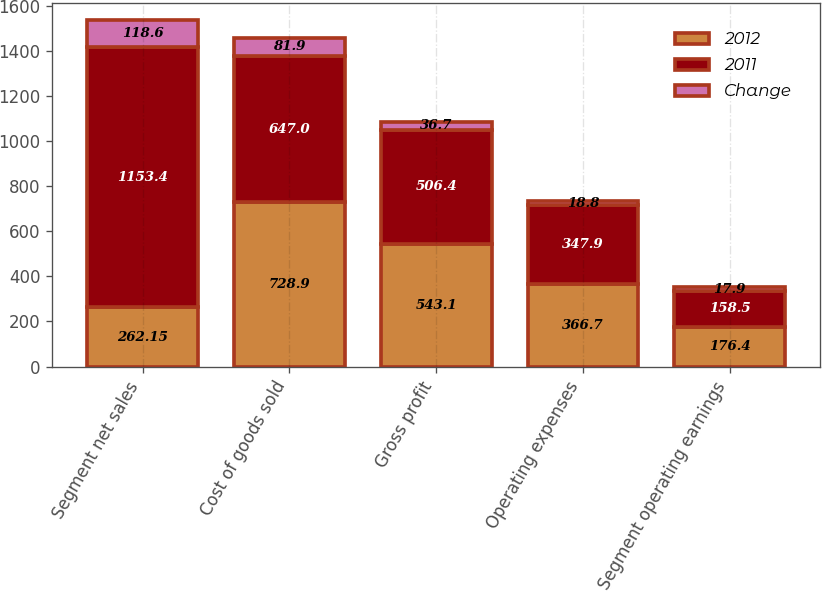<chart> <loc_0><loc_0><loc_500><loc_500><stacked_bar_chart><ecel><fcel>Segment net sales<fcel>Cost of goods sold<fcel>Gross profit<fcel>Operating expenses<fcel>Segment operating earnings<nl><fcel>2012<fcel>262.15<fcel>728.9<fcel>543.1<fcel>366.7<fcel>176.4<nl><fcel>2011<fcel>1153.4<fcel>647<fcel>506.4<fcel>347.9<fcel>158.5<nl><fcel>Change<fcel>118.6<fcel>81.9<fcel>36.7<fcel>18.8<fcel>17.9<nl></chart> 